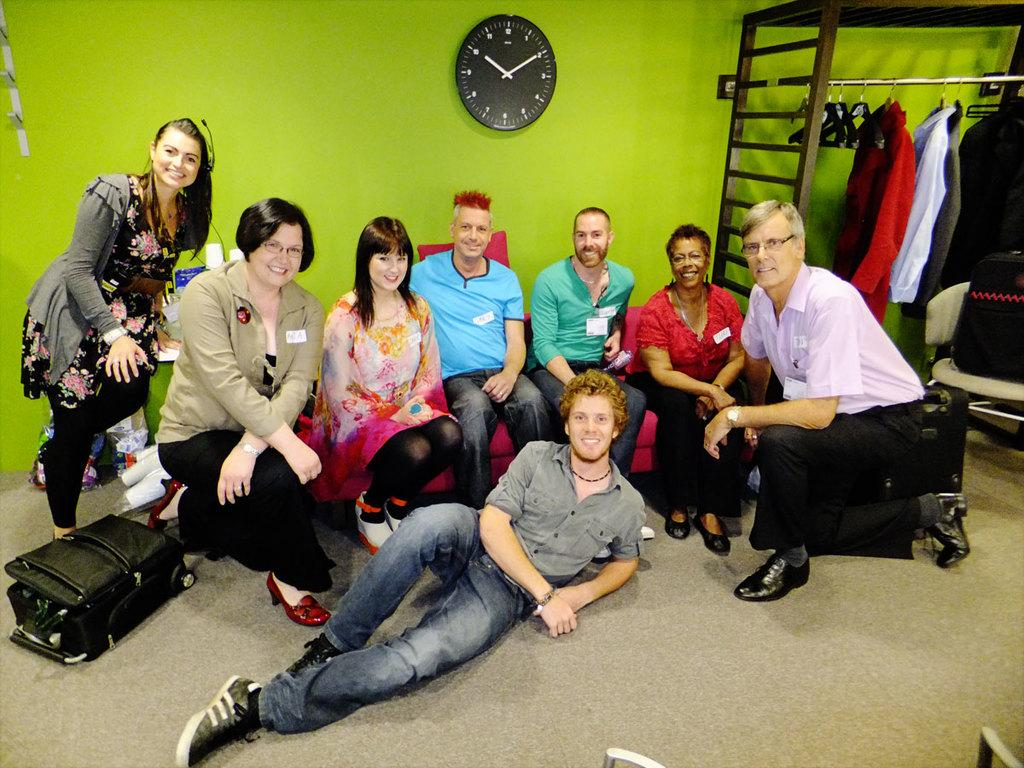How many people are present in the room in the image? There are many people in the room in the image. What are the people in the room doing? The people are looking and smiling at someone. What can be seen in the background of the image? There is a wall clock and clothes in the background. Where is the dock located in the image? There is no dock present in the image. What type of book is being read by the person in the image? There is no book or person reading a book present in the image. 